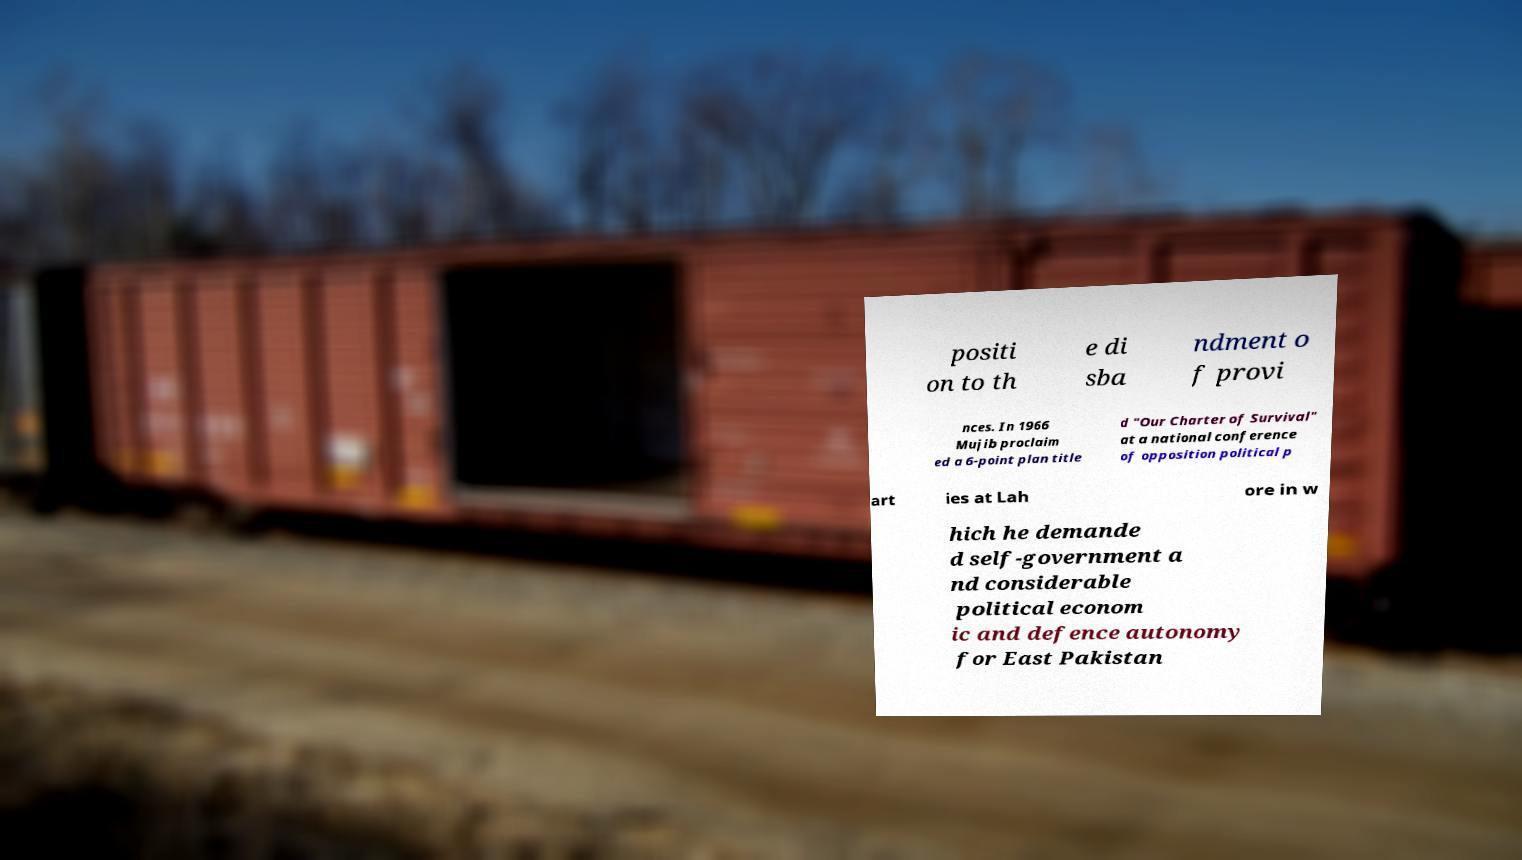I need the written content from this picture converted into text. Can you do that? positi on to th e di sba ndment o f provi nces. In 1966 Mujib proclaim ed a 6-point plan title d "Our Charter of Survival" at a national conference of opposition political p art ies at Lah ore in w hich he demande d self-government a nd considerable political econom ic and defence autonomy for East Pakistan 